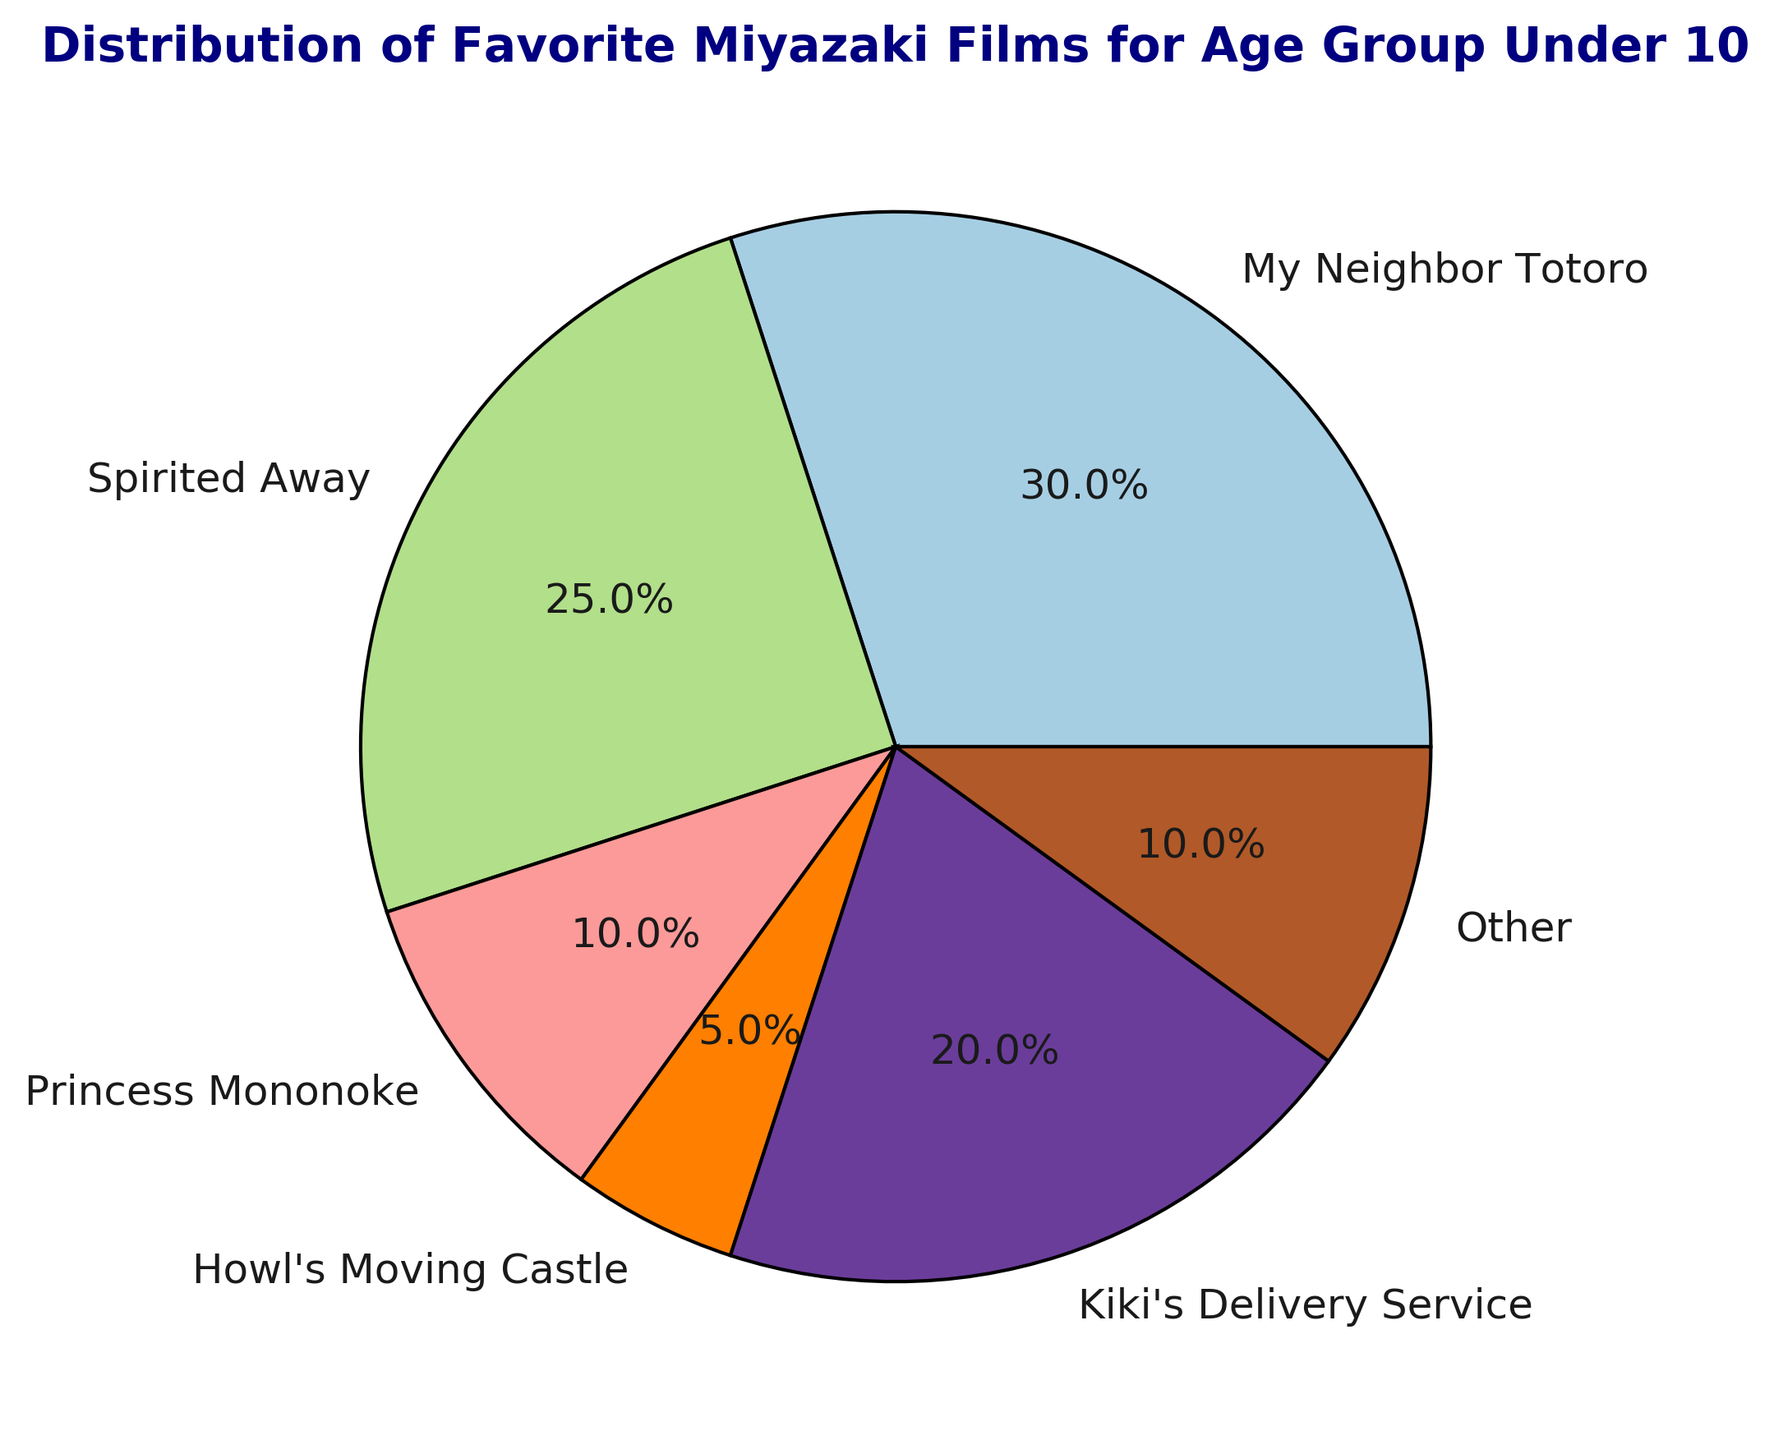What's the most popular Miyazaki film among the 20-30 age group? To determine this, look at the largest segment in the pie chart for the 20-30 age group. It is the segment labeled "Spirited Away".
Answer: Spirited Away Which age group has the highest preference for "My Neighbor Totoro"? Check the percentage of "My Neighbor Totoro" for each age group and find the highest value. The under 10 and 60+ groups both have 30%.
Answer: Under 10 and 60+ How does the preference for "Princess Mononoke" change as the age groups increase? Analyze the segments for each age group to see the trend for "Princess Mononoke". It starts low, peaks at 40-50, and decreases slightly after.
Answer: Increases and then decreases Compare the popularity of "Spirited Away" between the 10-20 and 40-50 age groups. Look at the pie chart segments for "Spirited Away" in the 10-20 and 40-50 age groups. The 10-20 group has 40% while the 40-50 group has 25%.
Answer: More popular in 10-20 Which film has the least popularity among the 50-60 age group? Identify the smallest segment of the pie chart for the 50-60 age group. It is "Other" with 5%.
Answer: Other Is "Howl's Moving Castle" more or less popular than "Kiki's Delivery Service" among all age groups? Compare the segments for "Howl's Moving Castle" and "Kiki's Delivery Service" in each age group. Generally, "Howl's Moving Castle" is less popular.
Answer: Less popular Which age group has an equal preference for both "Princess Mononoke" and "Kiki's Delivery Service"? Check the pie chart data for each age group to find equal segment sizes for "Princess Mononoke" and "Kiki's Delivery Service". No age groups have equal preferences.
Answer: None What is the total percentage for "Other" preferences across all age groups? Sum the percentages labeled "Other" for all pie charts. Each group has an "Other" value that needs to be added: 10+5+5+5+0+5+10=40.
Answer: 40% How does the popularity of "Kiki's Delivery Service" compare between the under 10 and the 20-30 age groups? Compare the segments representing "Kiki's Delivery Service" in the under 10 and 20-30 age groups. Under 10 has 20%, and 20-30 has 5%.
Answer: More popular in under 10 What is the cumulative preference for "Spirited Away" for age groups 10-20 and 20-30? Add the percentages for "Spirited Away" in the 10-20 and 20-30 age groups. 40% + 35% = 75%.
Answer: 75% 